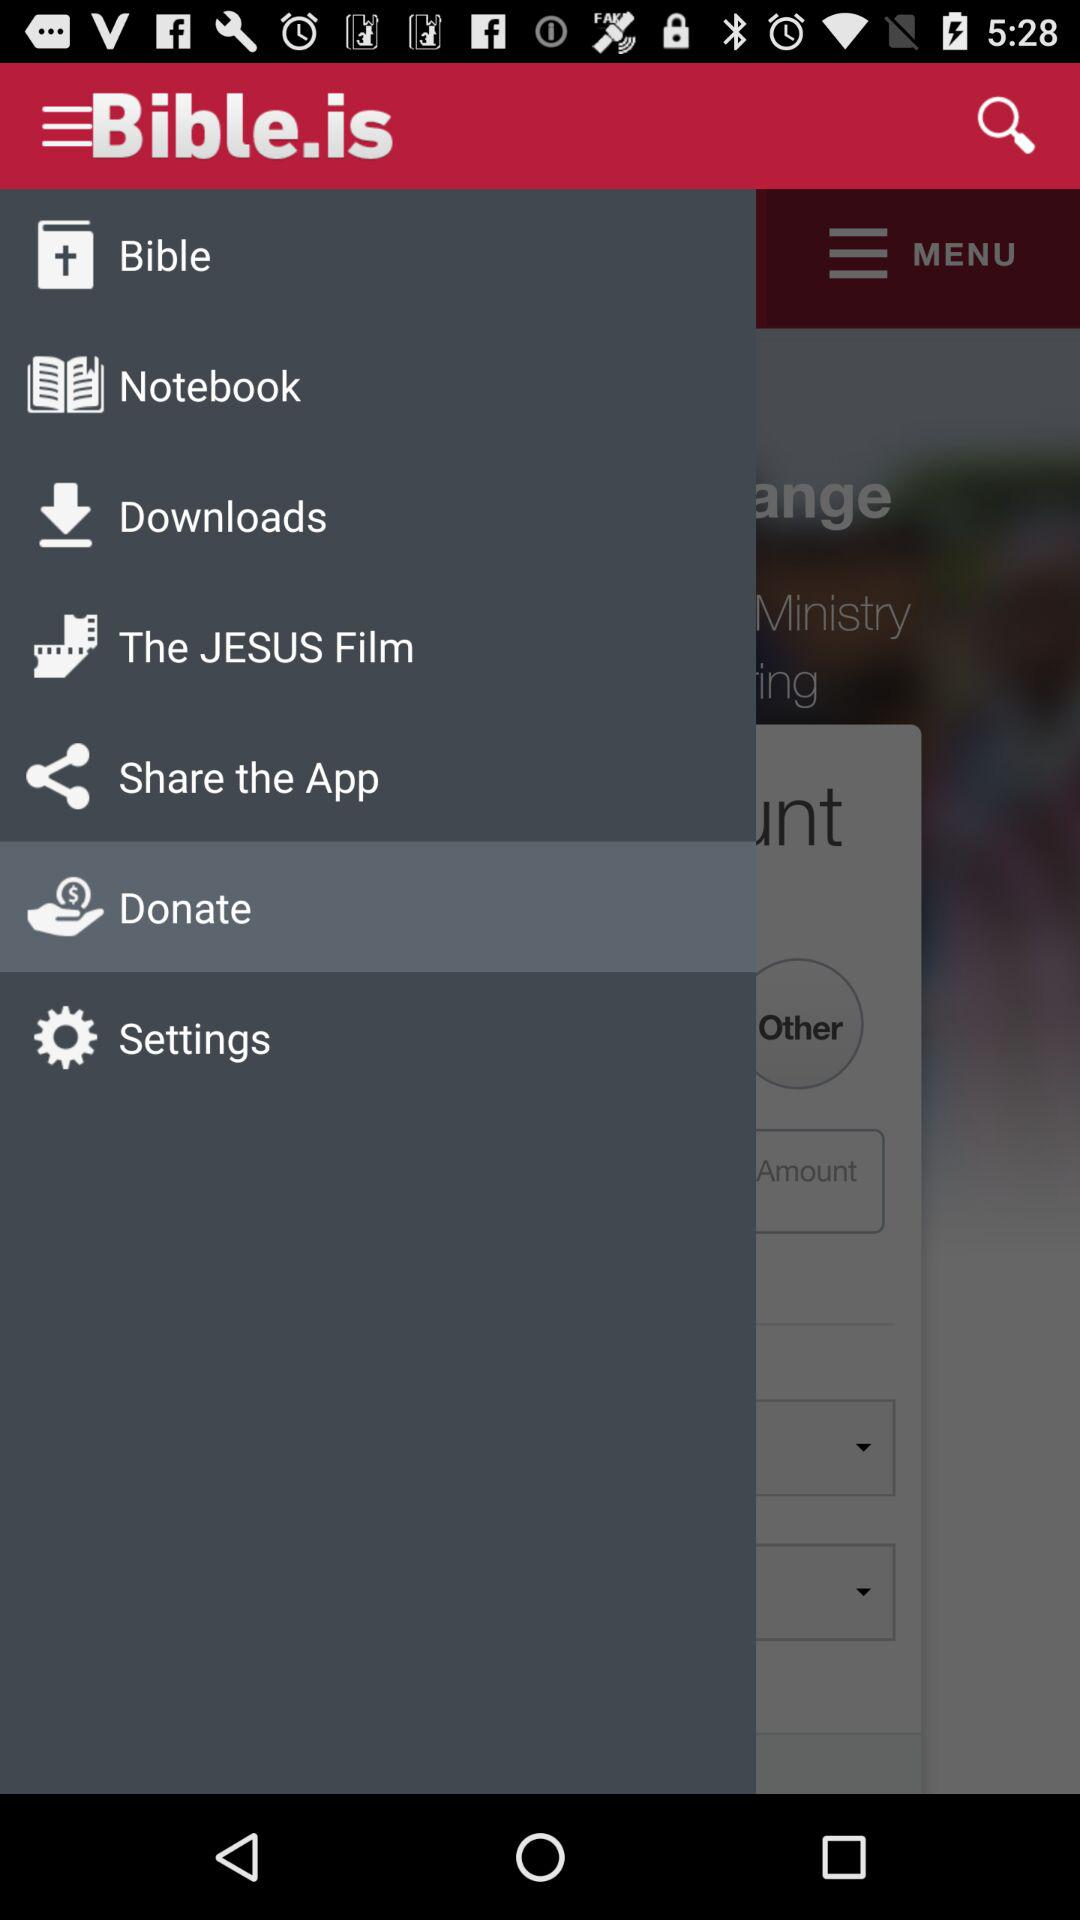What is the name of the application? The name of the application is "Bible.is". 